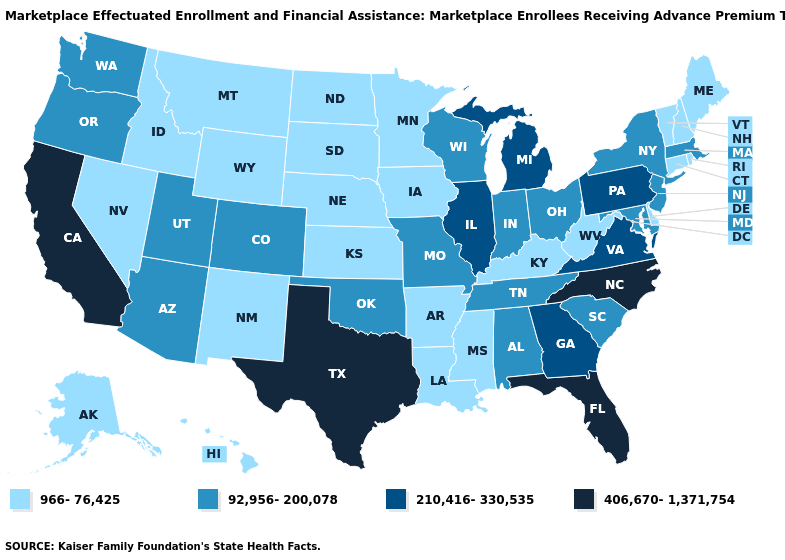What is the lowest value in states that border Michigan?
Answer briefly. 92,956-200,078. What is the lowest value in the USA?
Write a very short answer. 966-76,425. What is the highest value in the USA?
Give a very brief answer. 406,670-1,371,754. Does New Mexico have the same value as Nebraska?
Keep it brief. Yes. Name the states that have a value in the range 966-76,425?
Be succinct. Alaska, Arkansas, Connecticut, Delaware, Hawaii, Idaho, Iowa, Kansas, Kentucky, Louisiana, Maine, Minnesota, Mississippi, Montana, Nebraska, Nevada, New Hampshire, New Mexico, North Dakota, Rhode Island, South Dakota, Vermont, West Virginia, Wyoming. Does the first symbol in the legend represent the smallest category?
Short answer required. Yes. Among the states that border Vermont , does New York have the highest value?
Write a very short answer. Yes. What is the value of Indiana?
Quick response, please. 92,956-200,078. What is the value of Nebraska?
Keep it brief. 966-76,425. Does Florida have the highest value in the USA?
Short answer required. Yes. Which states have the highest value in the USA?
Write a very short answer. California, Florida, North Carolina, Texas. What is the value of Tennessee?
Quick response, please. 92,956-200,078. Does the first symbol in the legend represent the smallest category?
Be succinct. Yes. Does the map have missing data?
Be succinct. No. Name the states that have a value in the range 966-76,425?
Give a very brief answer. Alaska, Arkansas, Connecticut, Delaware, Hawaii, Idaho, Iowa, Kansas, Kentucky, Louisiana, Maine, Minnesota, Mississippi, Montana, Nebraska, Nevada, New Hampshire, New Mexico, North Dakota, Rhode Island, South Dakota, Vermont, West Virginia, Wyoming. 